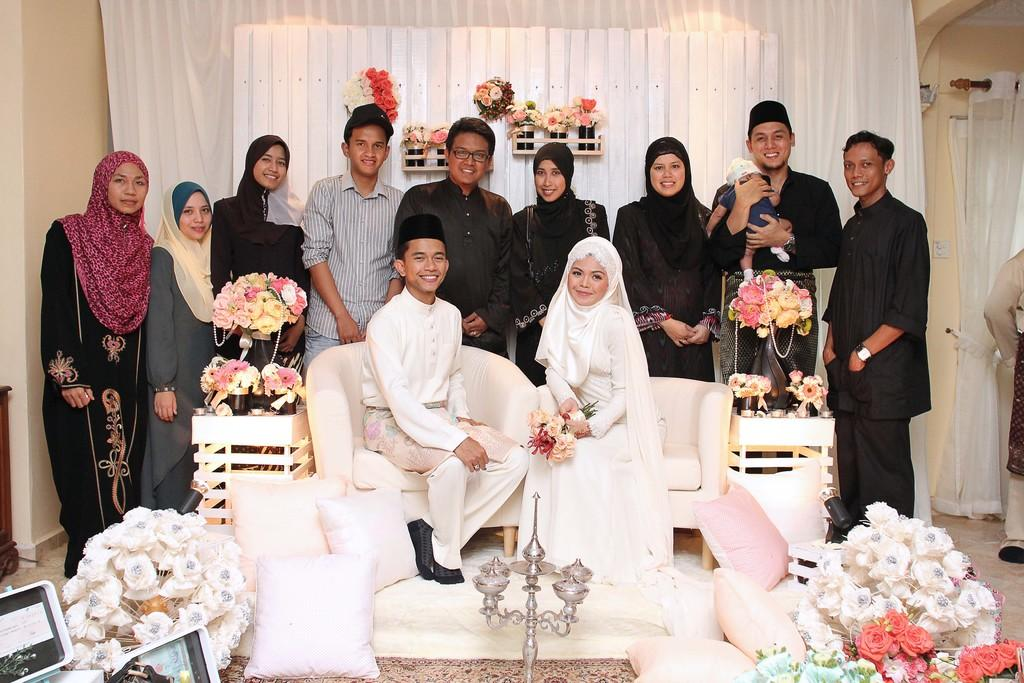How many people are sitting in the image? There are two people sitting on chairs in the image. What are the people behind the chairs doing? There are people standing behind the chairs in the image. What can be seen around the chairs in the image? Flowers are visible around the chairs in the image. What type of fruit is being used as a volleyball in the image? There is no fruit or volleyball present in the image. Can you describe the rifle that is being held by one of the people in the image? There is no rifle or any weapon present in the image. 